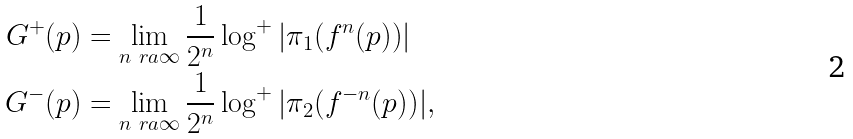Convert formula to latex. <formula><loc_0><loc_0><loc_500><loc_500>G ^ { + } ( p ) & = \lim _ { n \ r a \infty } \frac { 1 } { 2 ^ { n } } \log ^ { + } | \pi _ { 1 } ( f ^ { n } ( p ) ) | \\ G ^ { - } ( p ) & = \lim _ { n \ r a \infty } \frac { 1 } { 2 ^ { n } } \log ^ { + } | \pi _ { 2 } ( f ^ { - n } ( p ) ) | ,</formula> 